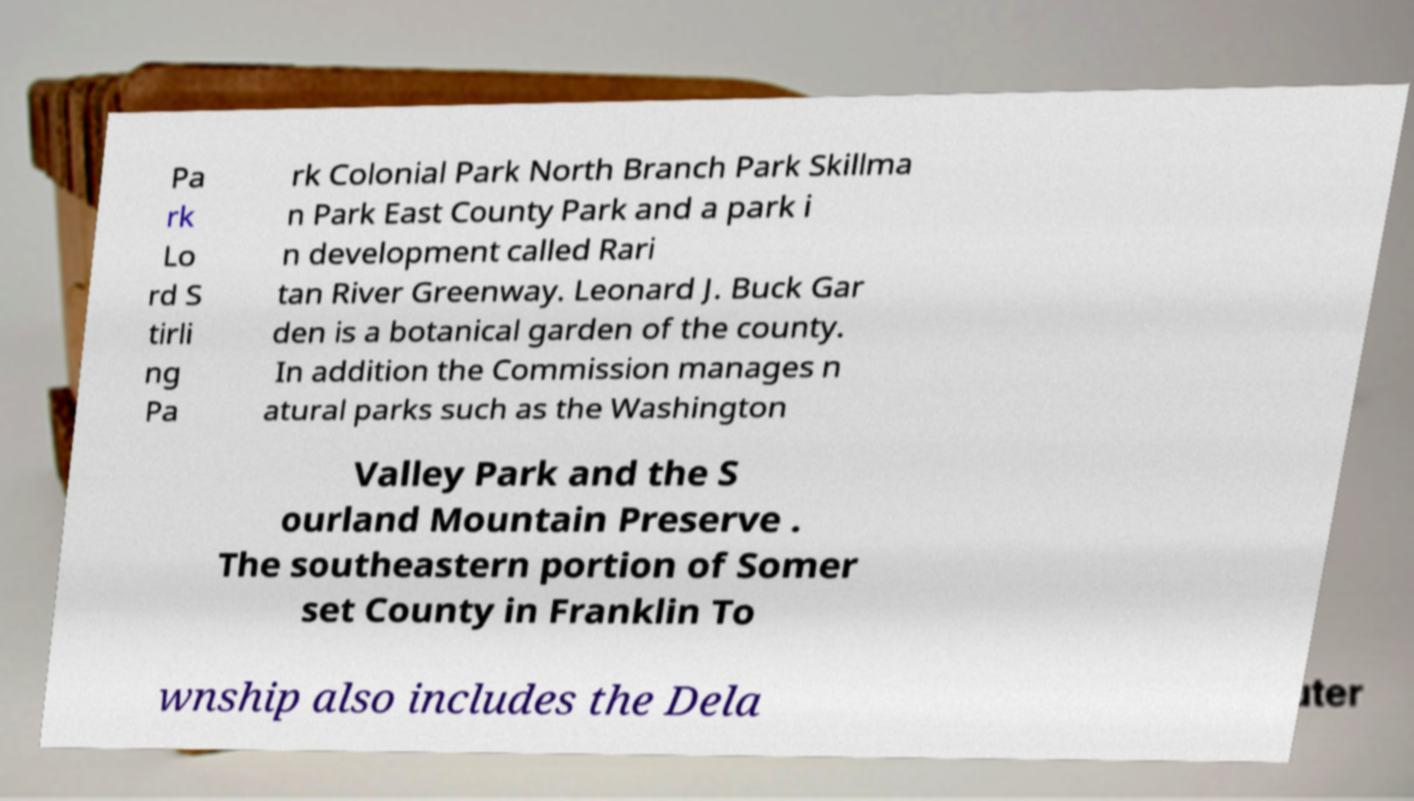Can you read and provide the text displayed in the image?This photo seems to have some interesting text. Can you extract and type it out for me? Pa rk Lo rd S tirli ng Pa rk Colonial Park North Branch Park Skillma n Park East County Park and a park i n development called Rari tan River Greenway. Leonard J. Buck Gar den is a botanical garden of the county. In addition the Commission manages n atural parks such as the Washington Valley Park and the S ourland Mountain Preserve . The southeastern portion of Somer set County in Franklin To wnship also includes the Dela 